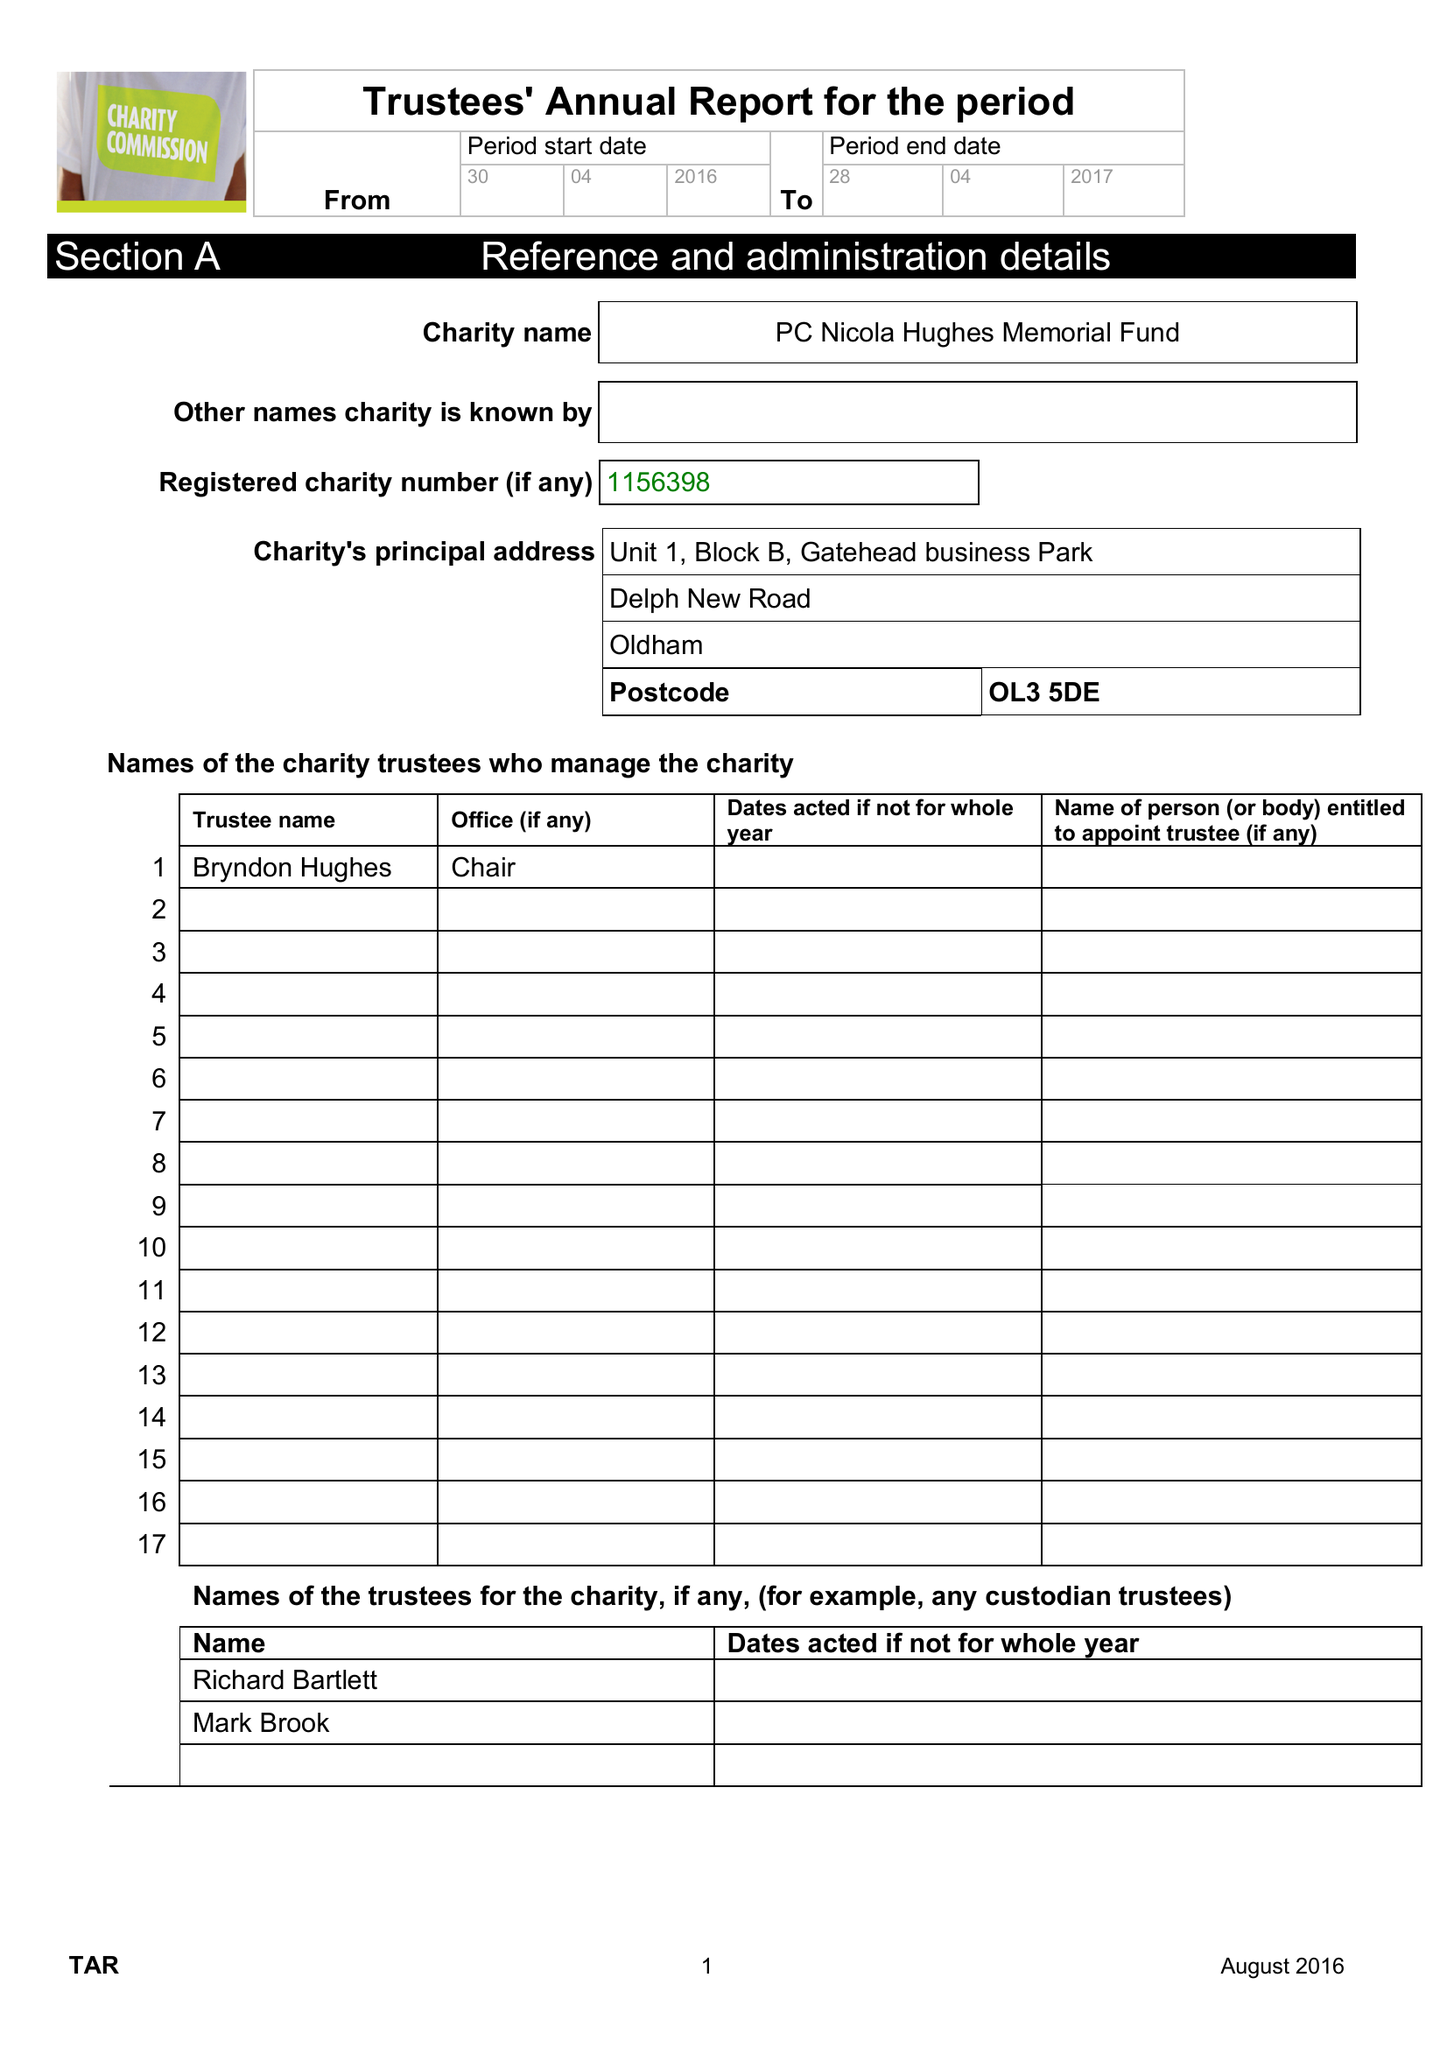What is the value for the address__postcode?
Answer the question using a single word or phrase. OL3 5DE 